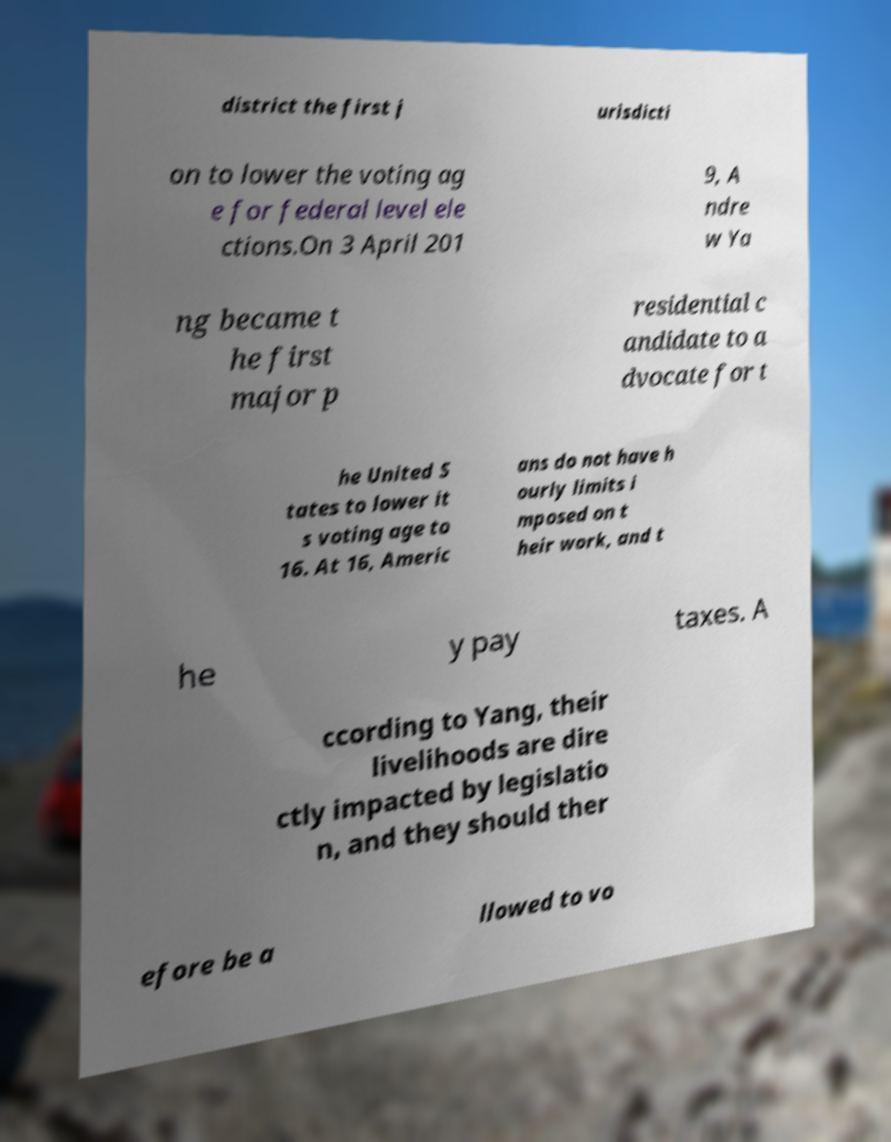Can you accurately transcribe the text from the provided image for me? district the first j urisdicti on to lower the voting ag e for federal level ele ctions.On 3 April 201 9, A ndre w Ya ng became t he first major p residential c andidate to a dvocate for t he United S tates to lower it s voting age to 16. At 16, Americ ans do not have h ourly limits i mposed on t heir work, and t he y pay taxes. A ccording to Yang, their livelihoods are dire ctly impacted by legislatio n, and they should ther efore be a llowed to vo 